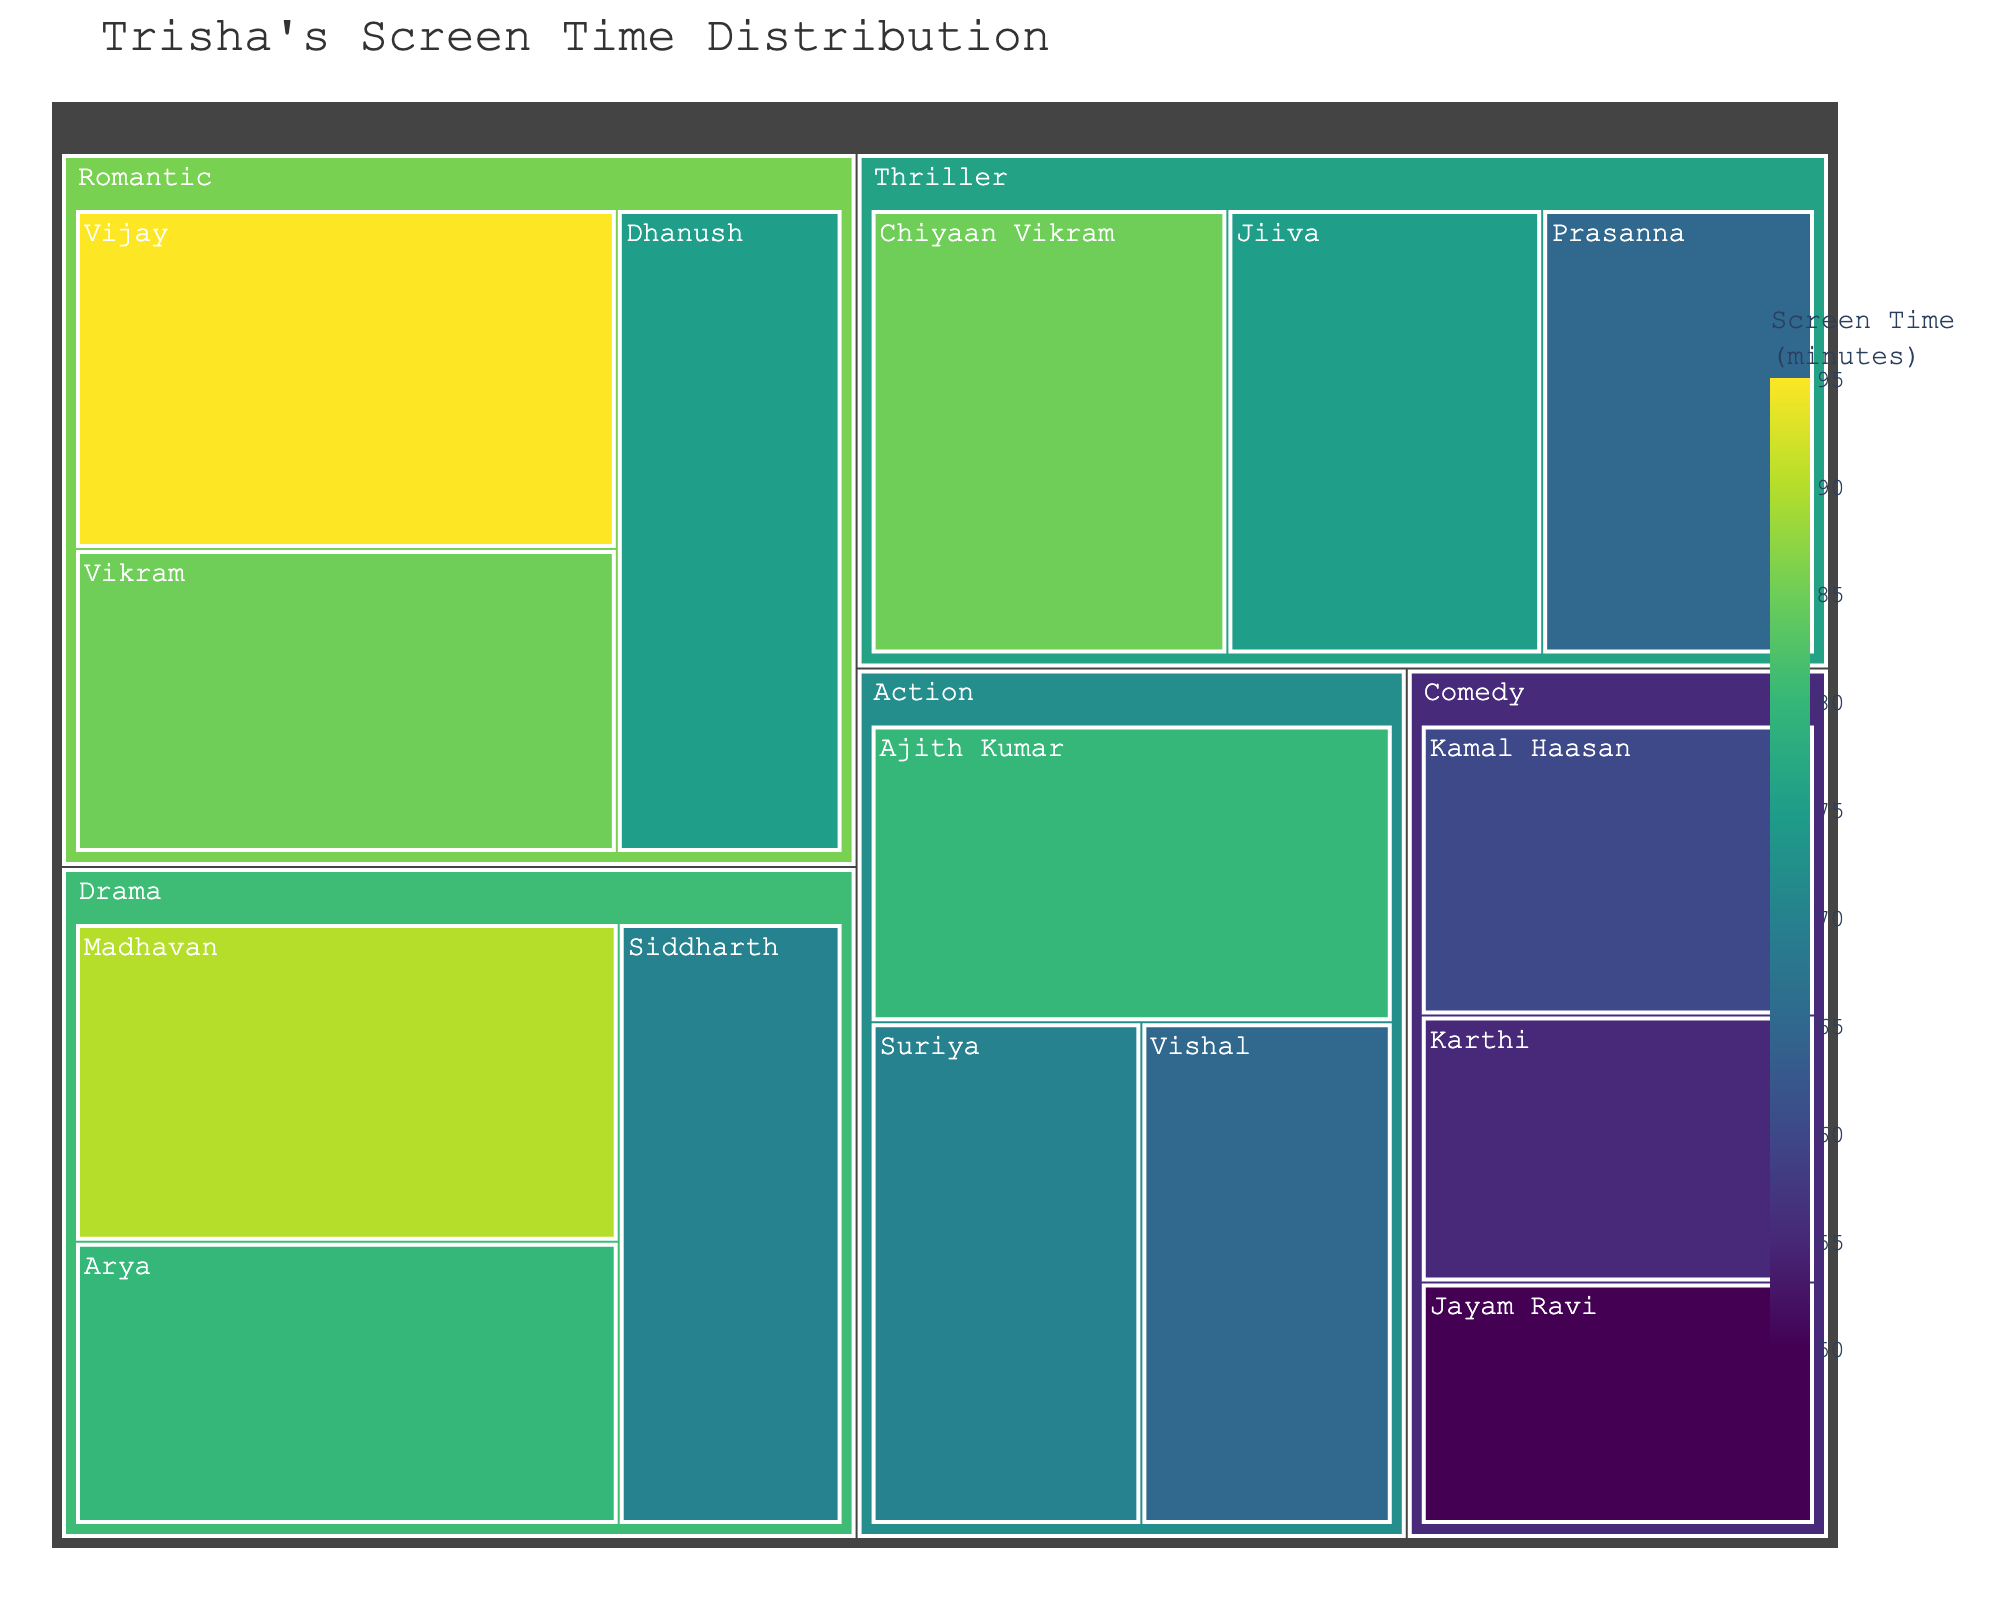What's the total screen time for the category 'Romantic'? Sum the screen time of all co-stars under the 'Romantic' category: 95 (Vijay) + 85 (Vikram) + 75 (Dhanush) = 255 minutes
Answer: 255 minutes Which category has the highest screen time for Trisha? Look for the category that has the largest overall screen time by summing up the screen time of all movies in each category. Romantic (255), Action (215), Comedy (165), Drama (240), Thriller (225). The highest is Romantic with 255 minutes
Answer: Romantic Who is Trisha's co-star in the 'Thriller' category with the least screen time? Identify the screen time for all co-stars in the 'Thriller' category and find the smallest value. Prasanna (65), Jiiva (75), Chiyaan Vikram (85). The least is Prasanna with 65 minutes
Answer: Prasanna Compare the total screen time between 'Action' and 'Drama' categories. Which is more? Calculate the total screen time for both categories: Action (80 + 70 + 65 = 215), Drama (90 + 80 + 70 = 240). Drama has more screen time than Action
Answer: Drama In which category does Trisha have the most varied screen time with different co-stars? Find the category with the maximum difference between the highest and lowest screen time. In Romantic, the difference is 95 - 75 = 20 minutes; in Action, 80 - 65 = 15 minutes; in Comedy, 60 - 50 = 10 minutes; in Drama, 90 - 70 = 20 minutes; in Thriller, 85 - 65 = 20 minutes. The categories Romantic, Drama, and Thriller have the same maximum variation of 20 minutes
Answer: Romantic, Drama, Thriller What is the average screen time for Trisha in the 'Comedy' category? Calculate the average by summing the screen time of all co-stars in Comedy and dividing by the number of co-stars: (60 + 55 + 50) / 3 = 165 / 3 = 55 minutes
Answer: 55 minutes Who are Trisha's co-stars in the 'Action' category and what is their combined screen time? List co-stars in Action (Ajith Kumar, Suriya, Vishal) and sum their screen time: 80 (Ajith Kumar) + 70 (Suriya) + 65 (Vishal) = 215 minutes
Answer: Ajith Kumar, Suriya, Vishal; 215 minutes Which co-star has the highest screen time with Trisha in any category? Find the highest screen time among all co-stars: Vijay in Romantic with 95 minutes
Answer: Vijay How much more screen time does Trisha have in 'Drama' compared to 'Comedy'? Calculate the difference in total screen time between Drama and Comedy: 240 (Drama) - 165 (Comedy) = 75 minutes
Answer: 75 minutes 